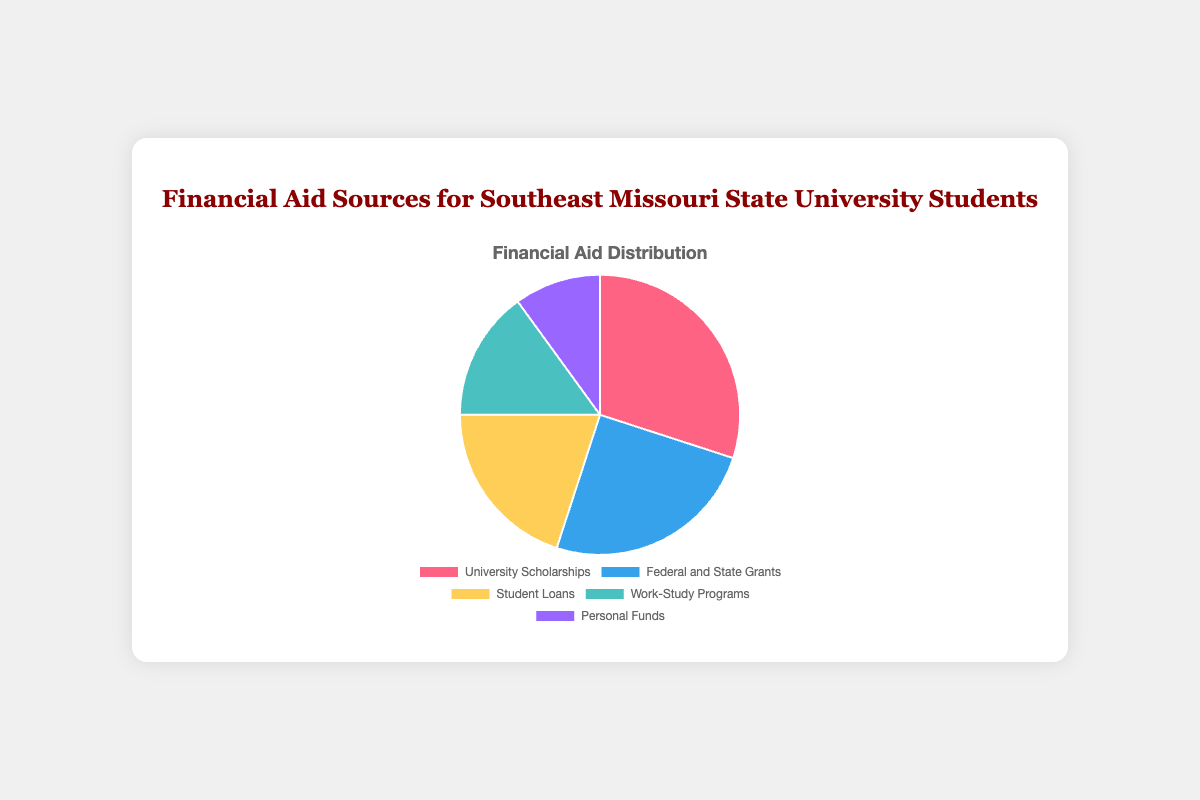What percentage of financial aid comes from University Scholarships? The chart shows different sources of financial aid with their respective percentages. By looking at the slice labeled 'University Scholarships,' we can see it accounts for 30% of the total financial aid.
Answer: 30% Which source contributes the least to financial aid? The chart has slices representing different sources. The slice with the smallest size is labeled 'Personal Funds,' which means personal funds contribute the least amount at 10%.
Answer: Personal Funds What is the combined percentage of Grants and Loans? The chart shows that 'Federal and State Grants' account for 25% and 'Student Loans' account for 20%. Adding these percentages gives us the combined contribution: 25% + 20% = 45%.
Answer: 45% Are Work-Study Programs more or less significant than Student Loans? By comparing the proportions of each slice, the slice for 'Student Loans' is larger than 'Work-Study Programs.' Student Loans account for 20%, while Work-Study Programs account for 15%. Therefore, Work-Study Programs are less significant than Student Loans.
Answer: Less significant What is the difference in percentage between the largest and smallest financial aid sources? From the chart, the largest source is University Scholarships at 30%, and the smallest is Personal Funds at 10%. The difference between them is 30% - 10% = 20%.
Answer: 20% Rank the financial aid sources from highest to lowest based on their percentage. By examining the chart's slices and their respective percentages, we can order them from highest to lowest: University Scholarships (30%), Federal and State Grants (25%), Student Loans (20%), Work-Study Programs (15%), and Personal Funds (10%).
Answer: University Scholarships, Federal and State Grants, Student Loans, Work-Study Programs, Personal Funds What percentage of financial aid does not come from loans? The percentage for Student Loans is 20%. The total percentage for all sources is 100%, so the percentage that does not come from loans is 100% - 20% = 80%.
Answer: 80% What color represents the Federal and State Grants slice? By looking at the chart's legend and matching the colors with the labels, the color representing 'Federal and State Grants' is blue.
Answer: Blue How much more significant are University Scholarships compared to Work-Study Programs? University Scholarships have a percentage of 30%, while Work-Study Programs have 15%. The difference in their significance is 30% - 15% = 15%.
Answer: 15% Do Federal and State Grants and Work-Study Programs together surpass University Scholarships in percentage? Federal and State Grants account for 25%, and Work-Study Programs account for 15%. Adding these gives us 25% + 15% = 40%, which is greater than the 30% of University Scholarships.
Answer: Yes 